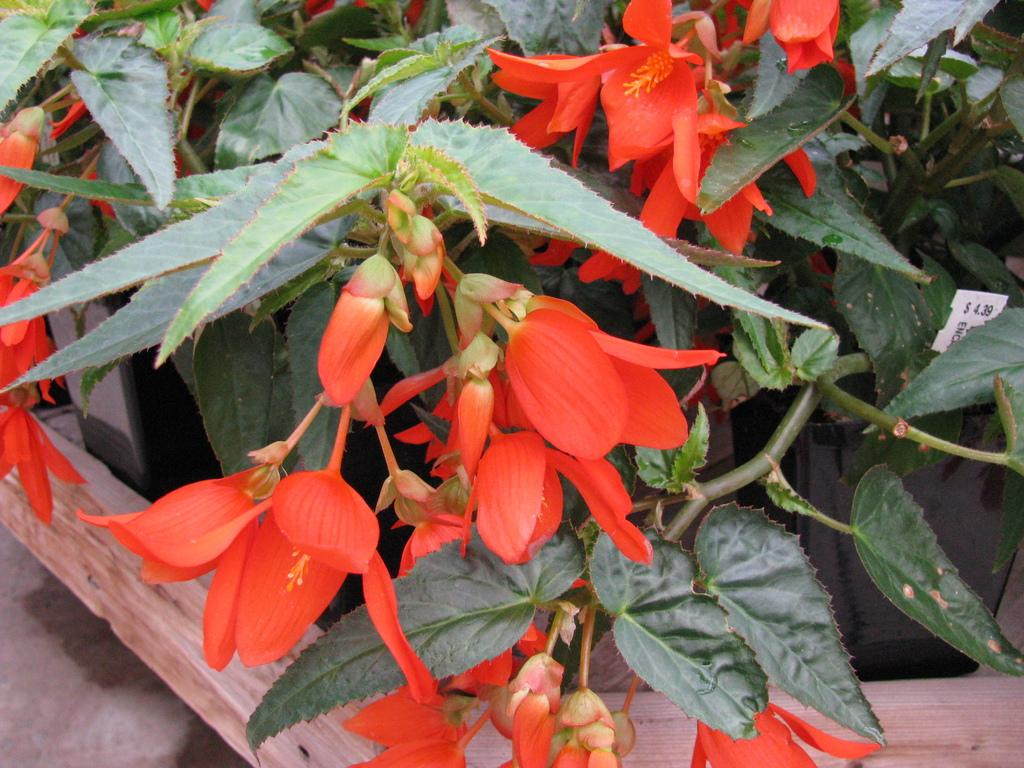What object is present in the image that can hold plants? There is a pot in the image that can hold plants. What is inside the pot? The pot contains a plant. What type of flowers are on the plant? There are red flowers on the plant. What color are the leaves on the plant? The leaves on the plant are green. What type of appliance is used to treat the wound on the plant? There is no wound on the plant, and no appliance is present in the image. 